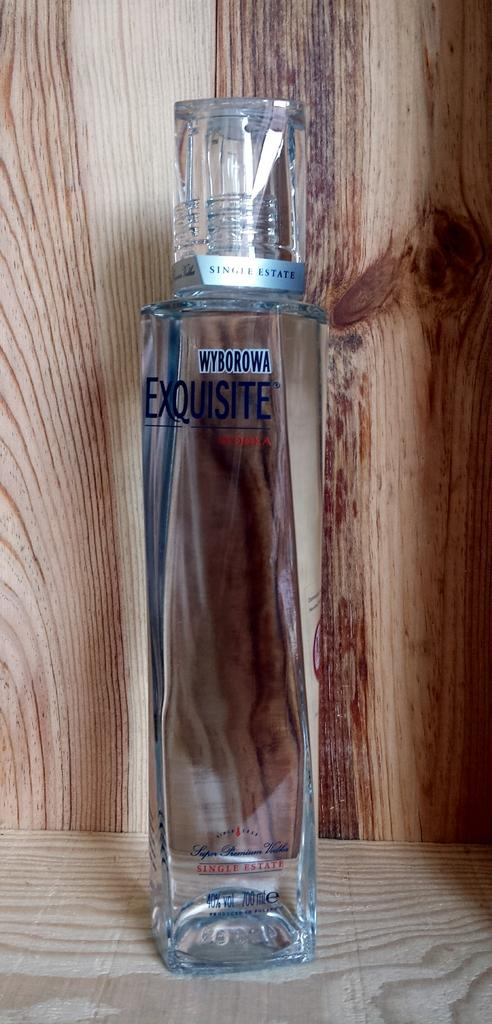<image>
Provide a brief description of the given image. A bottle of vodka that is from the brand Wyborowa 